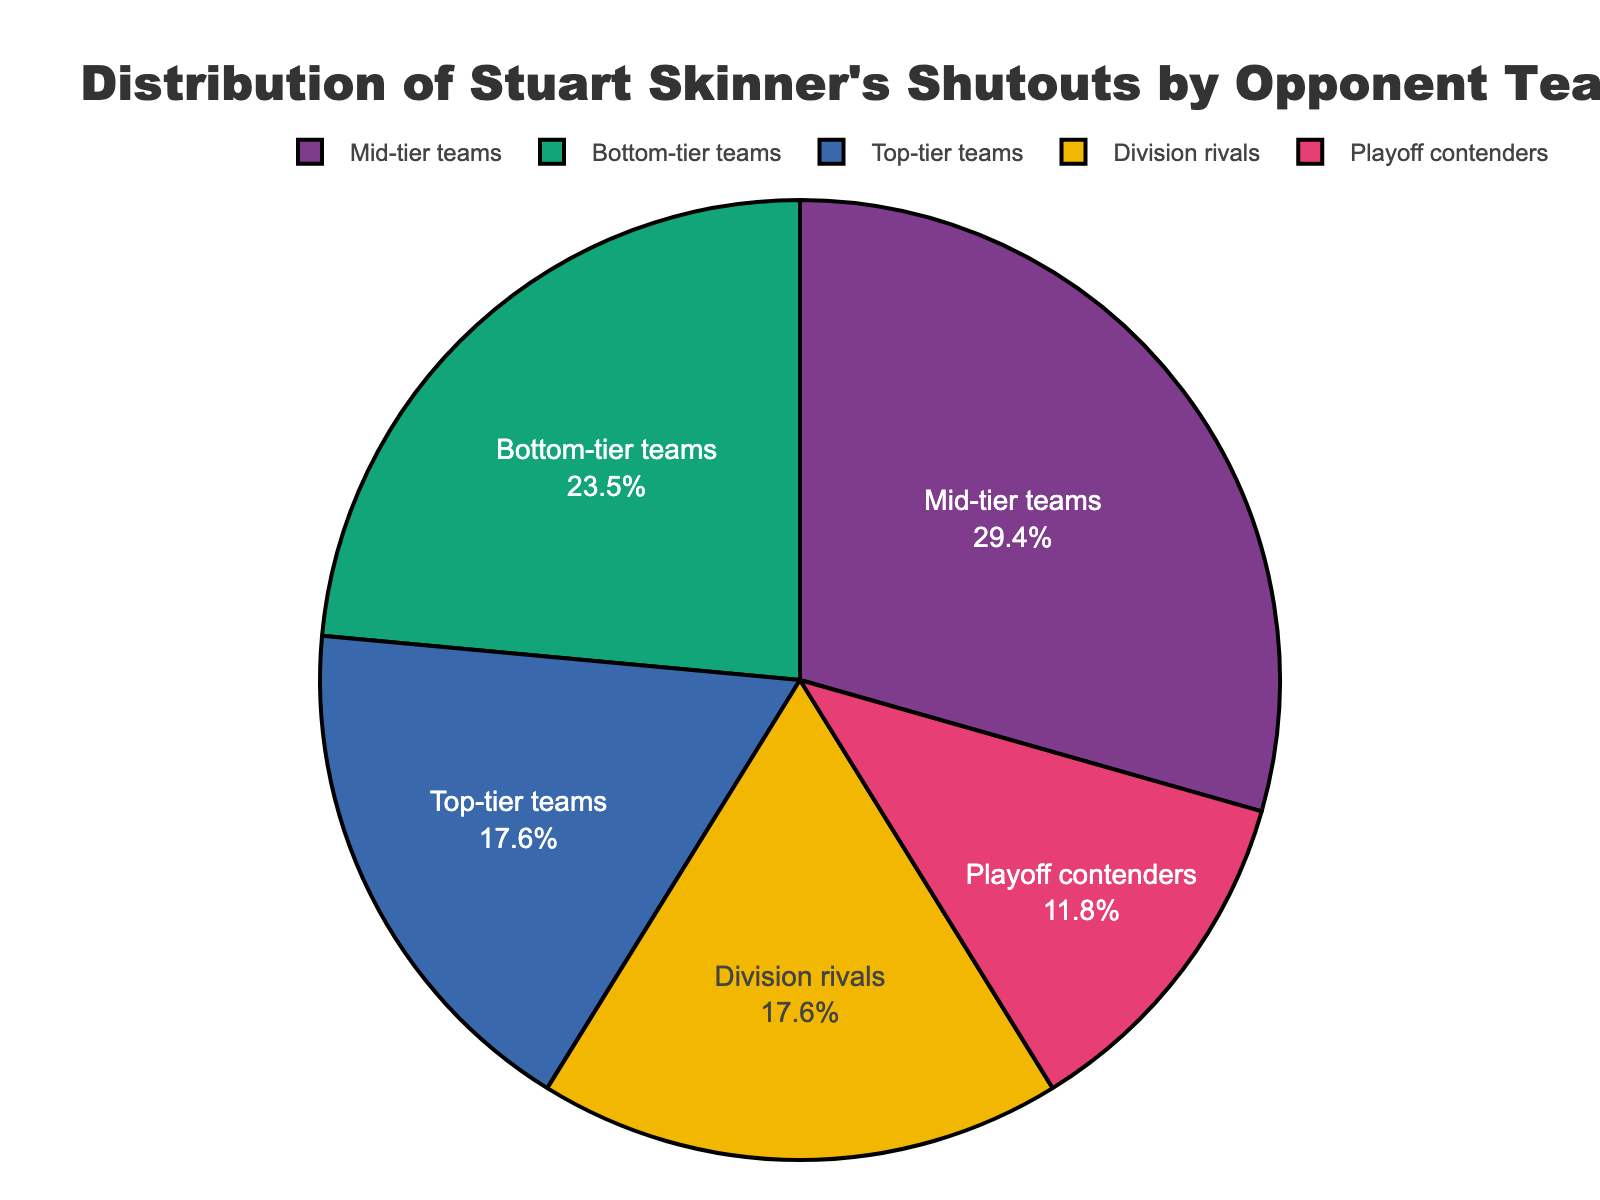What percentage of Stuart Skinner's shutouts came against mid-tier teams? By referring to the pie chart and looking at the section labeled "Mid-tier teams," we see it accounts for 5 shutouts. The total number of shutouts is 17. The percentage is calculated as (5/17) * 100.
Answer: 29.4% Which category had the most shutouts? By comparing the proportions of each slice in the pie chart, the "Mid-tier teams" section is the largest.
Answer: Mid-tier teams How many more shutouts did Stuart Skinner have against mid-tier teams than playoff contenders? Stuart Skinner had 5 shutouts against mid-tier teams and 2 against playoff contenders. The difference is calculated as 5 - 2.
Answer: 3 Are there more shutouts against bottom-tier teams or division rivals? By comparing the slices of the pie chart labeled "Bottom-tier teams" (4 shutouts) and "Division rivals" (3 shutouts), the bottom-tier teams have more shutouts.
Answer: Bottom-tier teams How many total shutouts does Stuart Skinner have against both top-tier and playoff contender teams combined? By adding the number of shutouts against top-tier teams (3) and playoff contenders (2), the total is 3 + 2.
Answer: 5 What's the difference in the number of shutouts between the team category with the highest and the lowest shutouts? The category with the highest shutouts is “Mid-tier teams” with 5, and the lowest is “Playoff contenders” with 2. The difference is 5 - 2.
Answer: 3 What percentage of shutouts came against either top-tier or bottom-tier teams? Summing the shutouts for top-tier (3) and bottom-tier teams (4) gives 7. Then, calculating the percentage of 7 out of the total 17 shutouts: (7/17) * 100.
Answer: 41.2% Which slice in the pie chart represents 2 shutouts? By looking at the chart, the slice labeled "Playoff contenders" represents 2 shutouts.
Answer: Playoff contenders If you combine the shutouts against division rivals and top-tier teams, do they outweigh the shutouts against mid-tier teams? Adding the shutouts against division rivals (3) and top-tier teams (3) gives 6, which is more than the 5 shutouts against mid-tier teams.
Answer: Yes 